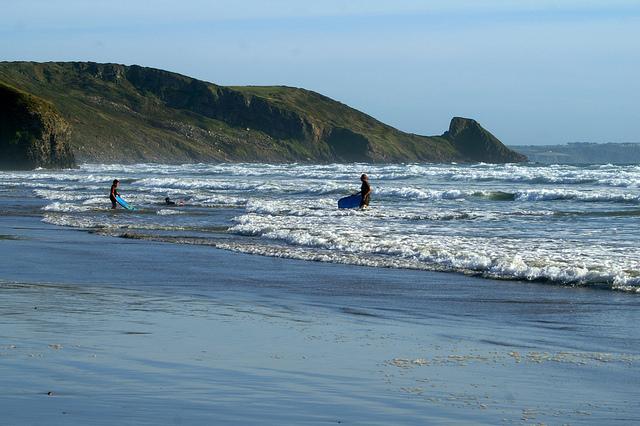Is it a sunny day?
Be succinct. Yes. Is it a cloudy day?
Short answer required. No. How deep is the water?
Short answer required. Shallow. Is it a good day to visit the beach?
Write a very short answer. Yes. Are the waves killer?
Give a very brief answer. No. How many surfers are in the water?
Give a very brief answer. 2. What are the people doing out on the water?
Short answer required. Surfing. 